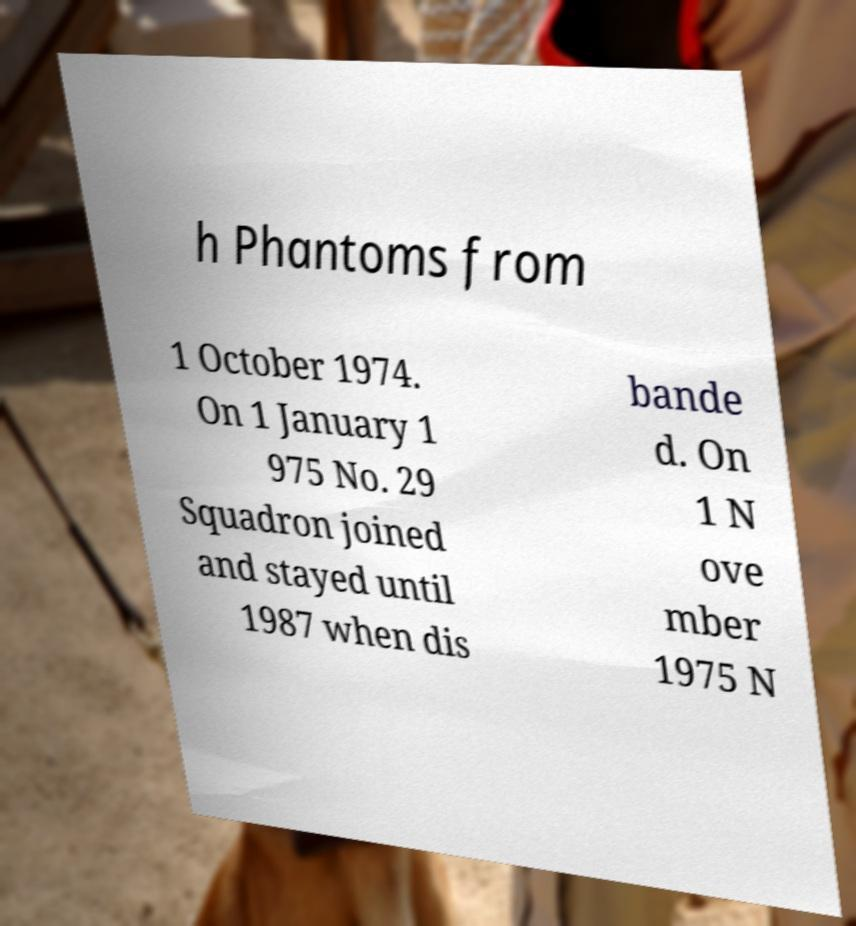What messages or text are displayed in this image? I need them in a readable, typed format. h Phantoms from 1 October 1974. On 1 January 1 975 No. 29 Squadron joined and stayed until 1987 when dis bande d. On 1 N ove mber 1975 N 